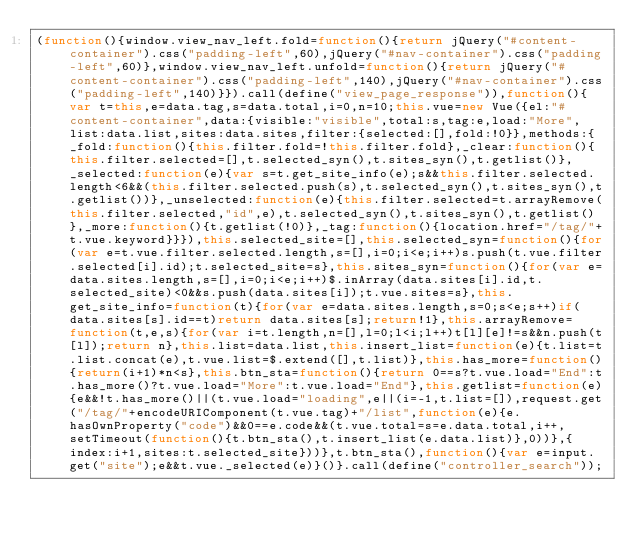Convert code to text. <code><loc_0><loc_0><loc_500><loc_500><_JavaScript_>(function(){window.view_nav_left.fold=function(){return jQuery("#content-container").css("padding-left",60),jQuery("#nav-container").css("padding-left",60)},window.view_nav_left.unfold=function(){return jQuery("#content-container").css("padding-left",140),jQuery("#nav-container").css("padding-left",140)}}).call(define("view_page_response")),function(){var t=this,e=data.tag,s=data.total,i=0,n=10;this.vue=new Vue({el:"#content-container",data:{visible:"visible",total:s,tag:e,load:"More",list:data.list,sites:data.sites,filter:{selected:[],fold:!0}},methods:{_fold:function(){this.filter.fold=!this.filter.fold},_clear:function(){this.filter.selected=[],t.selected_syn(),t.sites_syn(),t.getlist()},_selected:function(e){var s=t.get_site_info(e);s&&this.filter.selected.length<6&&(this.filter.selected.push(s),t.selected_syn(),t.sites_syn(),t.getlist())},_unselected:function(e){this.filter.selected=t.arrayRemove(this.filter.selected,"id",e),t.selected_syn(),t.sites_syn(),t.getlist()},_more:function(){t.getlist(!0)},_tag:function(){location.href="/tag/"+t.vue.keyword}}}),this.selected_site=[],this.selected_syn=function(){for(var e=t.vue.filter.selected.length,s=[],i=0;i<e;i++)s.push(t.vue.filter.selected[i].id);t.selected_site=s},this.sites_syn=function(){for(var e=data.sites.length,s=[],i=0;i<e;i++)$.inArray(data.sites[i].id,t.selected_site)<0&&s.push(data.sites[i]);t.vue.sites=s},this.get_site_info=function(t){for(var e=data.sites.length,s=0;s<e;s++)if(data.sites[s].id==t)return data.sites[s];return!1},this.arrayRemove=function(t,e,s){for(var i=t.length,n=[],l=0;l<i;l++)t[l][e]!=s&&n.push(t[l]);return n},this.list=data.list,this.insert_list=function(e){t.list=t.list.concat(e),t.vue.list=$.extend([],t.list)},this.has_more=function(){return(i+1)*n<s},this.btn_sta=function(){return 0==s?t.vue.load="End":t.has_more()?t.vue.load="More":t.vue.load="End"},this.getlist=function(e){e&&!t.has_more()||(t.vue.load="loading",e||(i=-1,t.list=[]),request.get("/tag/"+encodeURIComponent(t.vue.tag)+"/list",function(e){e.hasOwnProperty("code")&&0==e.code&&(t.vue.total=s=e.data.total,i++,setTimeout(function(){t.btn_sta(),t.insert_list(e.data.list)},0))},{index:i+1,sites:t.selected_site}))},t.btn_sta(),function(){var e=input.get("site");e&&t.vue._selected(e)}()}.call(define("controller_search"));</code> 